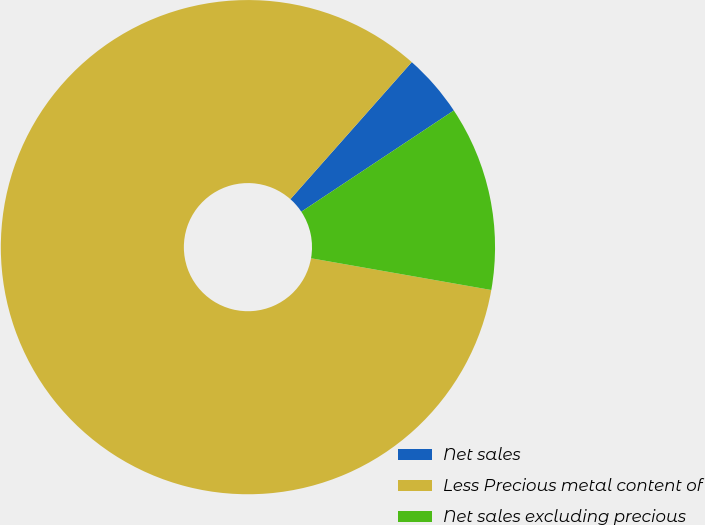Convert chart to OTSL. <chart><loc_0><loc_0><loc_500><loc_500><pie_chart><fcel>Net sales<fcel>Less Precious metal content of<fcel>Net sales excluding precious<nl><fcel>4.14%<fcel>83.76%<fcel>12.1%<nl></chart> 